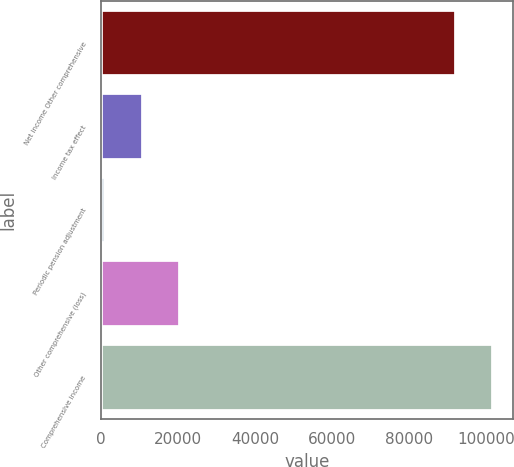Convert chart to OTSL. <chart><loc_0><loc_0><loc_500><loc_500><bar_chart><fcel>Net income Other comprehensive<fcel>Income tax effect<fcel>Periodic pension adjustment<fcel>Other comprehensive (loss)<fcel>Comprehensive income<nl><fcel>92170<fcel>10884.6<fcel>1228<fcel>20541.2<fcel>101827<nl></chart> 